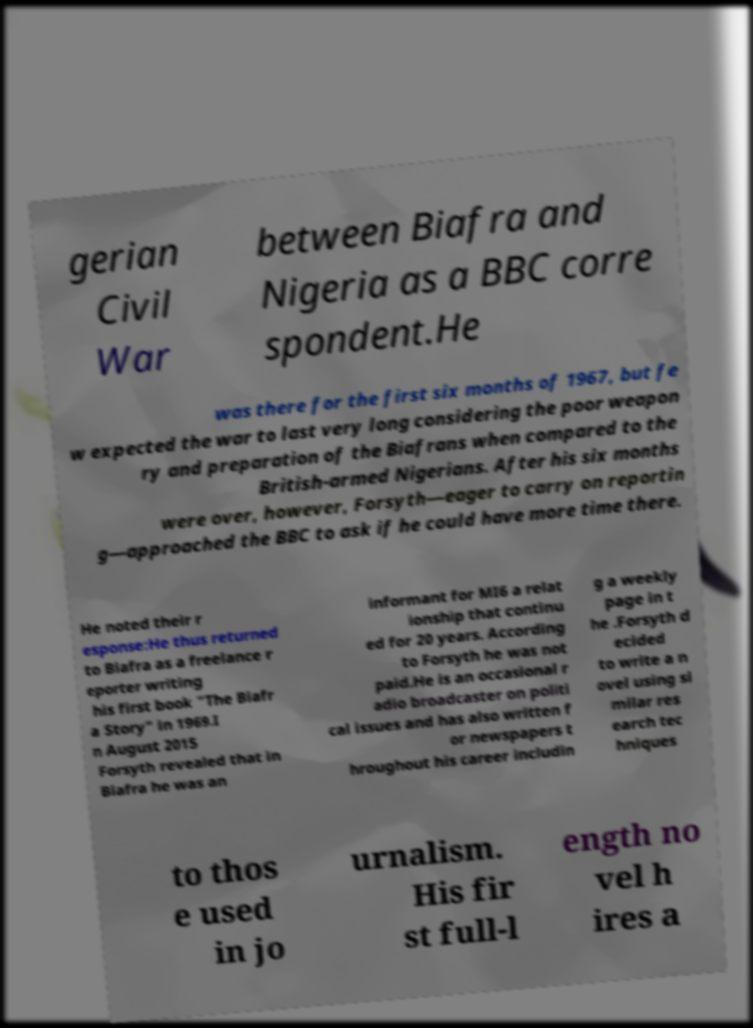Please identify and transcribe the text found in this image. gerian Civil War between Biafra and Nigeria as a BBC corre spondent.He was there for the first six months of 1967, but fe w expected the war to last very long considering the poor weapon ry and preparation of the Biafrans when compared to the British-armed Nigerians. After his six months were over, however, Forsyth—eager to carry on reportin g—approached the BBC to ask if he could have more time there. He noted their r esponse:He thus returned to Biafra as a freelance r eporter writing his first book "The Biafr a Story" in 1969.I n August 2015 Forsyth revealed that in Biafra he was an informant for MI6 a relat ionship that continu ed for 20 years. According to Forsyth he was not paid.He is an occasional r adio broadcaster on politi cal issues and has also written f or newspapers t hroughout his career includin g a weekly page in t he .Forsyth d ecided to write a n ovel using si milar res earch tec hniques to thos e used in jo urnalism. His fir st full-l ength no vel h ires a 